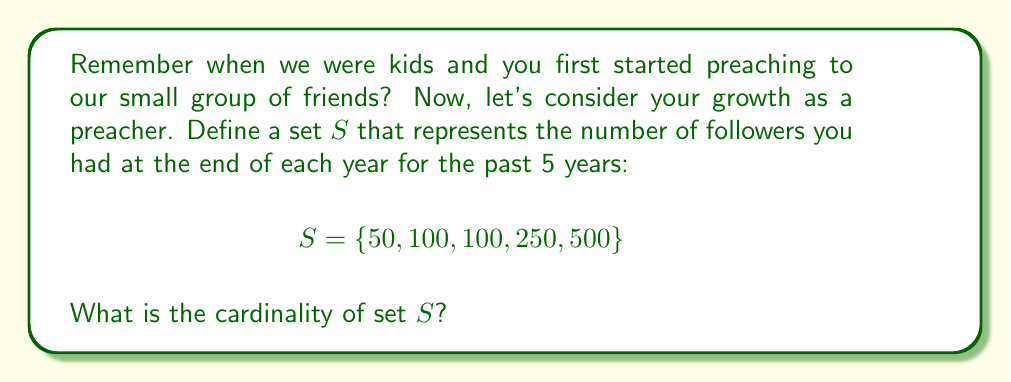Help me with this question. To determine the cardinality of set $S$, we need to count the number of unique elements in the set. Let's break this down step-by-step:

1) First, let's list out the elements of set $S$:
   $S = \{50, 100, 100, 250, 500\}$

2) Now, we need to identify the unique elements. In this case:
   - 50 appears once
   - 100 appears twice
   - 250 appears once
   - 500 appears once

3) Even though 100 appears twice, we only count it once when determining cardinality.

4) Therefore, the unique elements are:
   $\{50, 100, 250, 500\}$

5) To find the cardinality, we simply count these unique elements.

6) There are 4 unique elements in this set.

The cardinality of a set is denoted by vertical bars around the set symbol. So, we can write the cardinality of $S$ as $|S|$.

Therefore, $|S| = 4$.

This result shows that while you've had 5 years of growth, there were 4 distinct levels of followers during this time, reflecting your steady but non-linear growth from our small childhood group to your current following.
Answer: $|S| = 4$ 